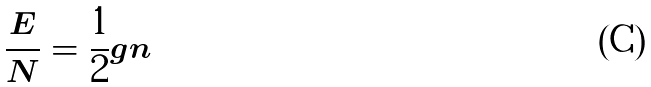Convert formula to latex. <formula><loc_0><loc_0><loc_500><loc_500>\frac { E } { N } = \frac { 1 } { 2 } g n</formula> 